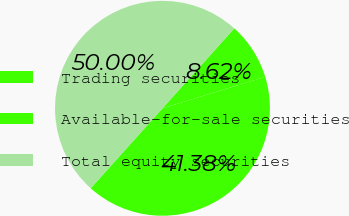Convert chart. <chart><loc_0><loc_0><loc_500><loc_500><pie_chart><fcel>Trading securities<fcel>Available-for-sale securities<fcel>Total equity securities<nl><fcel>8.62%<fcel>41.38%<fcel>50.0%<nl></chart> 